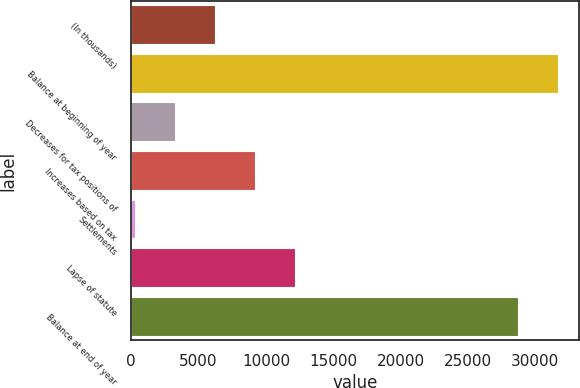Convert chart to OTSL. <chart><loc_0><loc_0><loc_500><loc_500><bar_chart><fcel>(In thousands)<fcel>Balance at beginning of year<fcel>Decreases for tax positions of<fcel>Increases based on tax<fcel>Settlements<fcel>Lapse of statute<fcel>Balance at end of year<nl><fcel>6234.2<fcel>31650.1<fcel>3269.1<fcel>9199.3<fcel>304<fcel>12164.4<fcel>28685<nl></chart> 